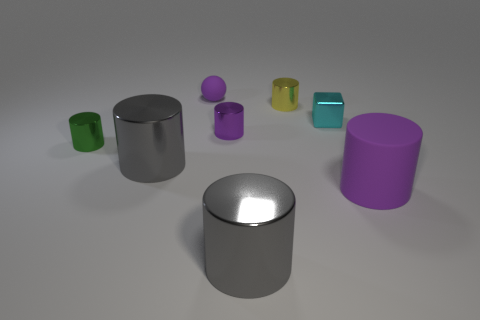Subtract all green spheres. How many gray cylinders are left? 2 Subtract all tiny green cylinders. How many cylinders are left? 5 Subtract all purple cylinders. How many cylinders are left? 4 Add 1 tiny metal objects. How many objects exist? 9 Subtract all yellow cylinders. Subtract all blue cubes. How many cylinders are left? 5 Subtract all blocks. How many objects are left? 7 Subtract all cylinders. Subtract all big purple things. How many objects are left? 1 Add 8 cyan shiny things. How many cyan shiny things are left? 9 Add 5 big metallic cylinders. How many big metallic cylinders exist? 7 Subtract 0 yellow balls. How many objects are left? 8 